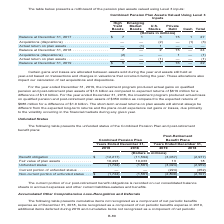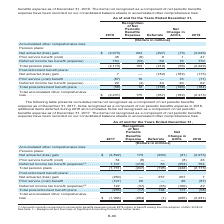According to Centurylink's financial document, Where are the items not recognized as a component of net periodic benefits expense recorded? on our consolidated balance sheets in accumulated other comprehensive loss. The document states: "net periodic benefits expense have been recorded on our consolidated balance sheets in accumulated other comprehensive loss:..." Also, The table presents cumulative items not recognized as a component of net periodic benefits expense as of which years? The document shows two values: 2018 and 2019. From the document: "Balance at December 31, 2019 . $ 5 — 1 16 — 22 Balance at December 31, 2019 . $ 5 — 1 16 — 22 Balance at December 31, 2019 . $ 5 — 1 16 — 22 Balance a..." Also, What is the Net actuarial (loss) gain for 2019? According to the financial document, (3,046) (in millions). The relevant text states: "t actuarial (loss) gain . $ (2,973) 224 (297) (73) (3,046) Prior service benefit (cost) . 46 (8) 9 1 47 Deferred income tax benefit (expense) . 754 (53) 69 16..." Additionally, Which year has a larger prior service benefit (cost) under pension plans? According to the financial document, 2019. The relevant text states: "Balance at December 31, 2019 . $ 5 — 1 16 — 22..." Also, can you calculate: What is the change in the deferred income tax benefit (expense) for pension plans in 2019 from 2018? Based on the calculation: 770-754, the result is 16 (in millions). This is based on the information: "8) 9 1 47 Deferred income tax benefit (expense) . 754 (53) 69 16 770 red income tax benefit (expense) . 754 (53) 69 16 770..." The key data points involved are: 754, 770. Also, can you calculate: What is the percentage change in the deferred income tax benefit (expense) for pension plans in 2019 from 2018? To answer this question, I need to perform calculations using the financial data. The calculation is: (770-754)/754, which equals 2.12 (percentage). This is based on the information: "8) 9 1 47 Deferred income tax benefit (expense) . 754 (53) 69 16 770 red income tax benefit (expense) . 754 (53) 69 16 770..." The key data points involved are: 754, 770. 